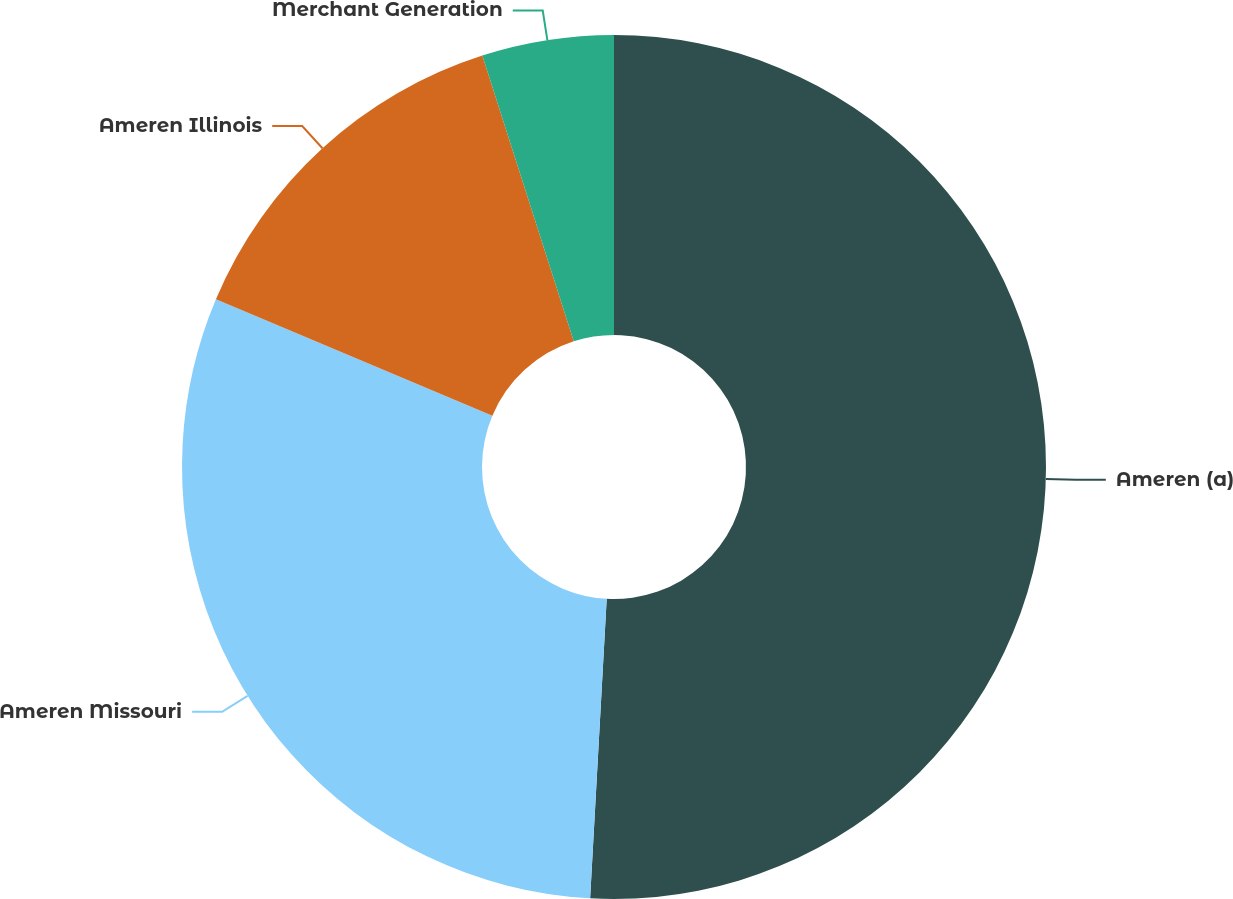Convert chart to OTSL. <chart><loc_0><loc_0><loc_500><loc_500><pie_chart><fcel>Ameren (a)<fcel>Ameren Missouri<fcel>Ameren Illinois<fcel>Merchant Generation<nl><fcel>50.88%<fcel>30.47%<fcel>13.72%<fcel>4.93%<nl></chart> 